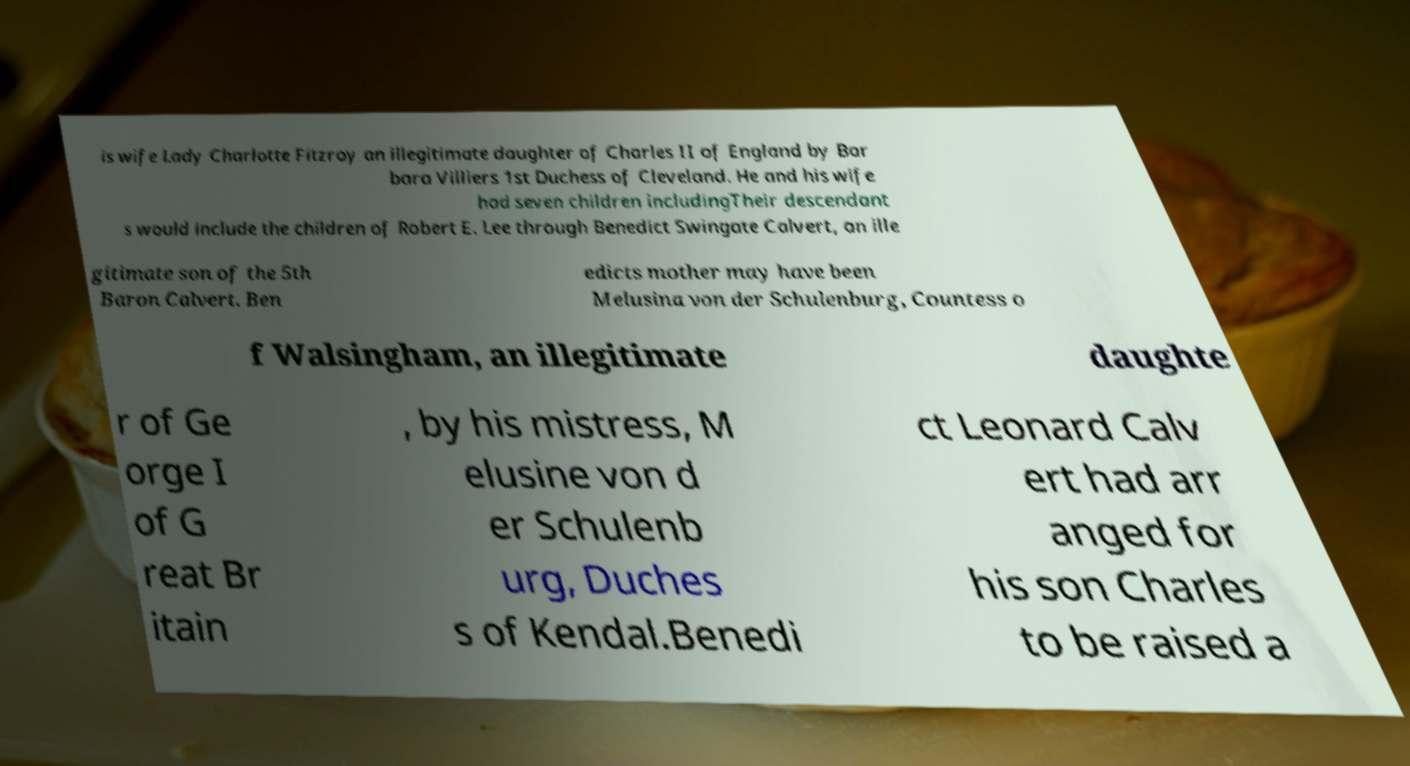Please identify and transcribe the text found in this image. is wife Lady Charlotte Fitzroy an illegitimate daughter of Charles II of England by Bar bara Villiers 1st Duchess of Cleveland. He and his wife had seven children includingTheir descendant s would include the children of Robert E. Lee through Benedict Swingate Calvert, an ille gitimate son of the 5th Baron Calvert. Ben edicts mother may have been Melusina von der Schulenburg, Countess o f Walsingham, an illegitimate daughte r of Ge orge I of G reat Br itain , by his mistress, M elusine von d er Schulenb urg, Duches s of Kendal.Benedi ct Leonard Calv ert had arr anged for his son Charles to be raised a 